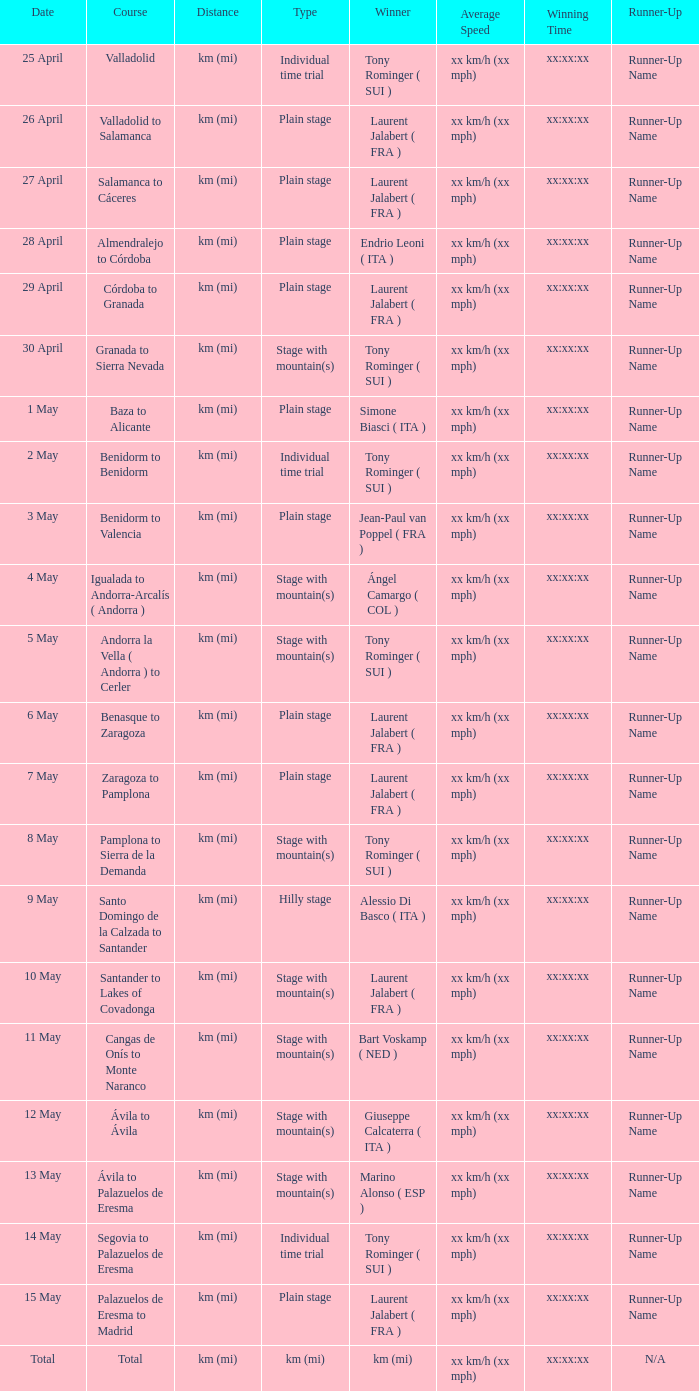What was the date with a winner of km (mi)? Total. 